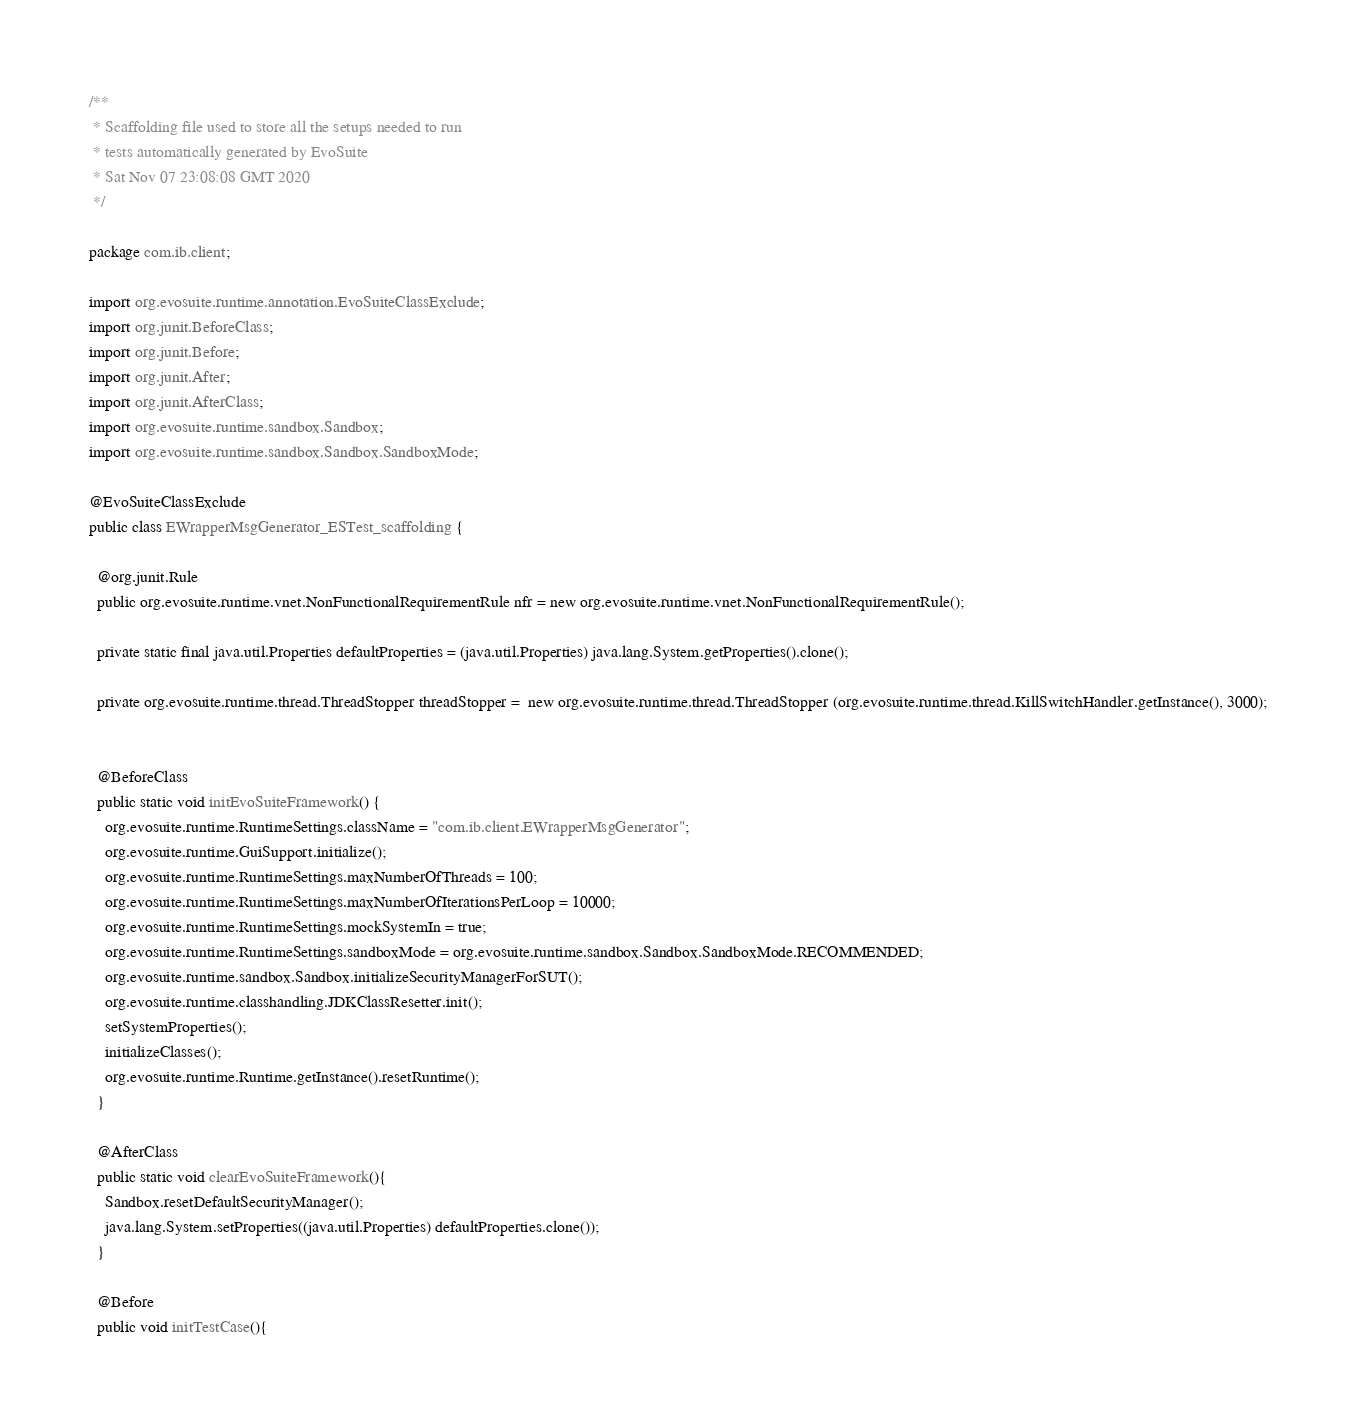Convert code to text. <code><loc_0><loc_0><loc_500><loc_500><_Java_>/**
 * Scaffolding file used to store all the setups needed to run 
 * tests automatically generated by EvoSuite
 * Sat Nov 07 23:08:08 GMT 2020
 */

package com.ib.client;

import org.evosuite.runtime.annotation.EvoSuiteClassExclude;
import org.junit.BeforeClass;
import org.junit.Before;
import org.junit.After;
import org.junit.AfterClass;
import org.evosuite.runtime.sandbox.Sandbox;
import org.evosuite.runtime.sandbox.Sandbox.SandboxMode;

@EvoSuiteClassExclude
public class EWrapperMsgGenerator_ESTest_scaffolding {

  @org.junit.Rule 
  public org.evosuite.runtime.vnet.NonFunctionalRequirementRule nfr = new org.evosuite.runtime.vnet.NonFunctionalRequirementRule();

  private static final java.util.Properties defaultProperties = (java.util.Properties) java.lang.System.getProperties().clone(); 

  private org.evosuite.runtime.thread.ThreadStopper threadStopper =  new org.evosuite.runtime.thread.ThreadStopper (org.evosuite.runtime.thread.KillSwitchHandler.getInstance(), 3000);


  @BeforeClass 
  public static void initEvoSuiteFramework() { 
    org.evosuite.runtime.RuntimeSettings.className = "com.ib.client.EWrapperMsgGenerator"; 
    org.evosuite.runtime.GuiSupport.initialize(); 
    org.evosuite.runtime.RuntimeSettings.maxNumberOfThreads = 100; 
    org.evosuite.runtime.RuntimeSettings.maxNumberOfIterationsPerLoop = 10000; 
    org.evosuite.runtime.RuntimeSettings.mockSystemIn = true; 
    org.evosuite.runtime.RuntimeSettings.sandboxMode = org.evosuite.runtime.sandbox.Sandbox.SandboxMode.RECOMMENDED; 
    org.evosuite.runtime.sandbox.Sandbox.initializeSecurityManagerForSUT(); 
    org.evosuite.runtime.classhandling.JDKClassResetter.init();
    setSystemProperties();
    initializeClasses();
    org.evosuite.runtime.Runtime.getInstance().resetRuntime(); 
  } 

  @AfterClass 
  public static void clearEvoSuiteFramework(){ 
    Sandbox.resetDefaultSecurityManager(); 
    java.lang.System.setProperties((java.util.Properties) defaultProperties.clone()); 
  } 

  @Before 
  public void initTestCase(){ </code> 